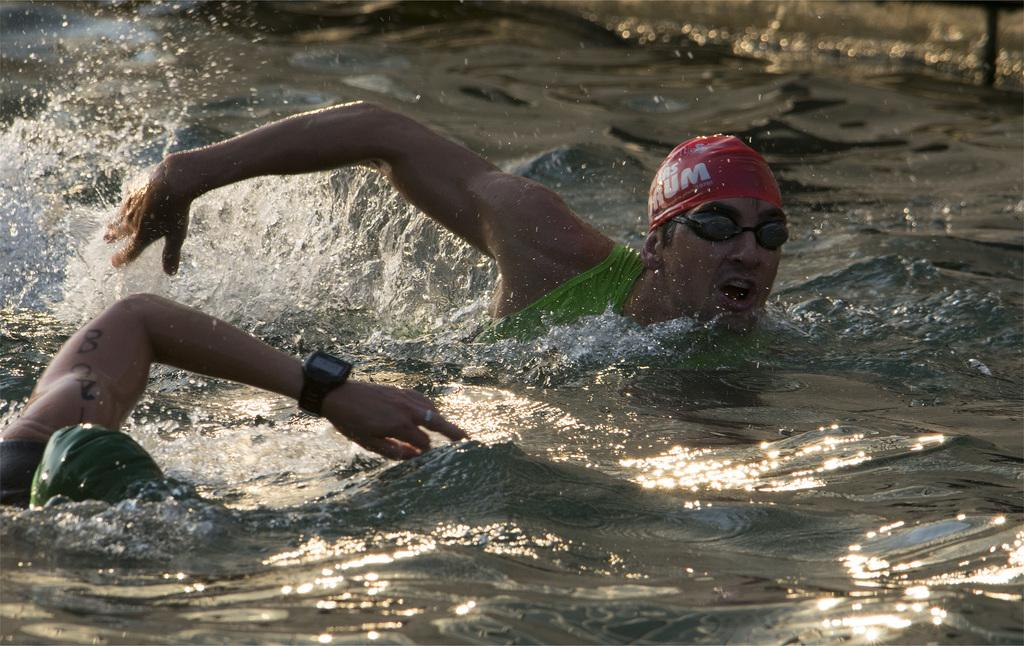How many people are in the image? There are two people in the image. What are the two people doing in the image? The two people are swimming in the water. What type of society can be seen in the image? There is no society present in the image; it features two people swimming in the water. How many hands are visible in the image? The number of hands visible in the image cannot be determined from the provided facts, as the focus is on the two people swimming. 